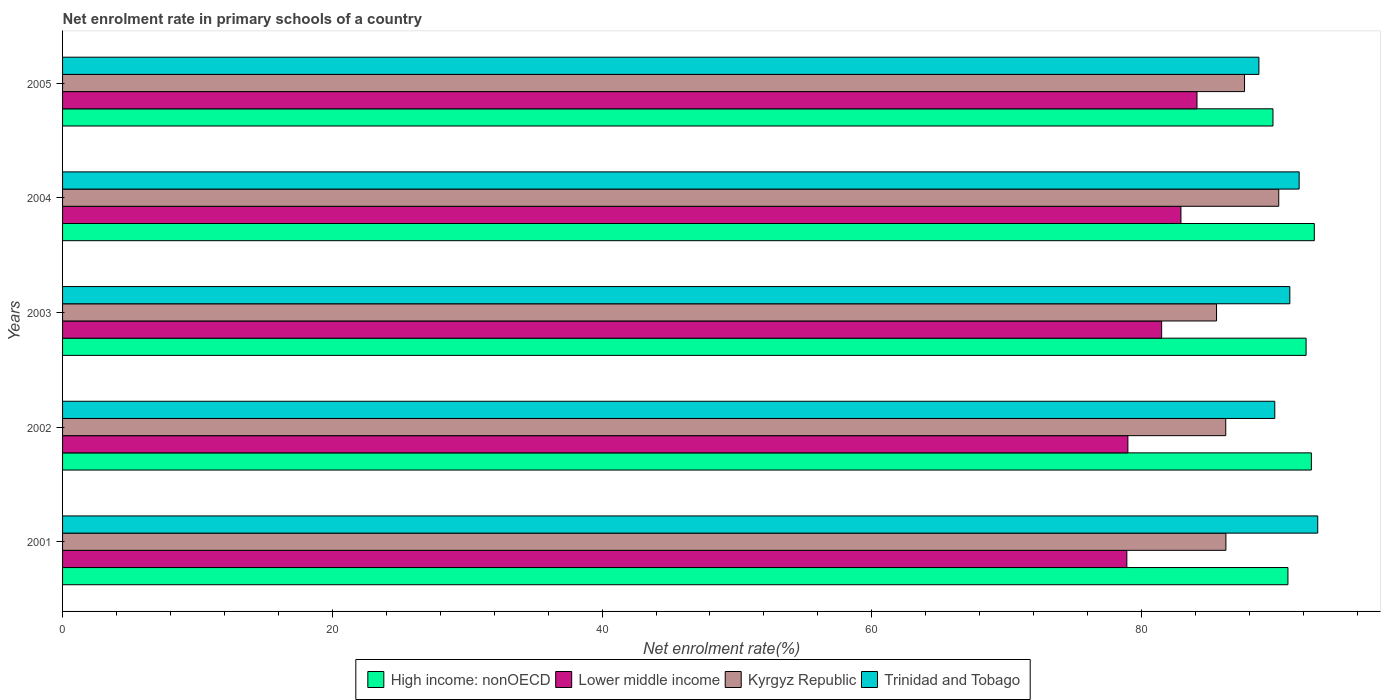How many bars are there on the 1st tick from the top?
Keep it short and to the point. 4. How many bars are there on the 5th tick from the bottom?
Give a very brief answer. 4. In how many cases, is the number of bars for a given year not equal to the number of legend labels?
Provide a short and direct response. 0. What is the net enrolment rate in primary schools in Lower middle income in 2004?
Your answer should be very brief. 82.92. Across all years, what is the maximum net enrolment rate in primary schools in High income: nonOECD?
Make the answer very short. 92.81. Across all years, what is the minimum net enrolment rate in primary schools in High income: nonOECD?
Offer a very short reply. 89.74. What is the total net enrolment rate in primary schools in Lower middle income in the graph?
Provide a short and direct response. 406.42. What is the difference between the net enrolment rate in primary schools in Trinidad and Tobago in 2002 and that in 2004?
Your response must be concise. -1.81. What is the difference between the net enrolment rate in primary schools in Trinidad and Tobago in 2001 and the net enrolment rate in primary schools in Kyrgyz Republic in 2003?
Make the answer very short. 7.5. What is the average net enrolment rate in primary schools in Lower middle income per year?
Your answer should be very brief. 81.28. In the year 2003, what is the difference between the net enrolment rate in primary schools in Kyrgyz Republic and net enrolment rate in primary schools in Trinidad and Tobago?
Keep it short and to the point. -5.43. In how many years, is the net enrolment rate in primary schools in Trinidad and Tobago greater than 44 %?
Offer a very short reply. 5. What is the ratio of the net enrolment rate in primary schools in Lower middle income in 2004 to that in 2005?
Your response must be concise. 0.99. Is the difference between the net enrolment rate in primary schools in Kyrgyz Republic in 2001 and 2004 greater than the difference between the net enrolment rate in primary schools in Trinidad and Tobago in 2001 and 2004?
Provide a short and direct response. No. What is the difference between the highest and the second highest net enrolment rate in primary schools in Trinidad and Tobago?
Ensure brevity in your answer.  1.38. What is the difference between the highest and the lowest net enrolment rate in primary schools in Trinidad and Tobago?
Your answer should be very brief. 4.36. In how many years, is the net enrolment rate in primary schools in Trinidad and Tobago greater than the average net enrolment rate in primary schools in Trinidad and Tobago taken over all years?
Your response must be concise. 3. What does the 1st bar from the top in 2004 represents?
Make the answer very short. Trinidad and Tobago. What does the 4th bar from the bottom in 2001 represents?
Ensure brevity in your answer.  Trinidad and Tobago. Is it the case that in every year, the sum of the net enrolment rate in primary schools in Kyrgyz Republic and net enrolment rate in primary schools in High income: nonOECD is greater than the net enrolment rate in primary schools in Trinidad and Tobago?
Make the answer very short. Yes. Are all the bars in the graph horizontal?
Provide a short and direct response. Yes. Are the values on the major ticks of X-axis written in scientific E-notation?
Provide a short and direct response. No. Does the graph contain any zero values?
Offer a very short reply. No. Does the graph contain grids?
Provide a succinct answer. No. Where does the legend appear in the graph?
Make the answer very short. Bottom center. What is the title of the graph?
Ensure brevity in your answer.  Net enrolment rate in primary schools of a country. What is the label or title of the X-axis?
Offer a terse response. Net enrolment rate(%). What is the Net enrolment rate(%) in High income: nonOECD in 2001?
Offer a very short reply. 90.85. What is the Net enrolment rate(%) of Lower middle income in 2001?
Offer a terse response. 78.91. What is the Net enrolment rate(%) in Kyrgyz Republic in 2001?
Offer a very short reply. 86.25. What is the Net enrolment rate(%) of Trinidad and Tobago in 2001?
Your response must be concise. 93.06. What is the Net enrolment rate(%) of High income: nonOECD in 2002?
Ensure brevity in your answer.  92.59. What is the Net enrolment rate(%) in Lower middle income in 2002?
Your answer should be compact. 78.99. What is the Net enrolment rate(%) of Kyrgyz Republic in 2002?
Your answer should be very brief. 86.24. What is the Net enrolment rate(%) in Trinidad and Tobago in 2002?
Offer a very short reply. 89.88. What is the Net enrolment rate(%) of High income: nonOECD in 2003?
Ensure brevity in your answer.  92.2. What is the Net enrolment rate(%) of Lower middle income in 2003?
Ensure brevity in your answer.  81.49. What is the Net enrolment rate(%) of Kyrgyz Republic in 2003?
Your answer should be very brief. 85.56. What is the Net enrolment rate(%) in Trinidad and Tobago in 2003?
Give a very brief answer. 90.99. What is the Net enrolment rate(%) in High income: nonOECD in 2004?
Offer a very short reply. 92.81. What is the Net enrolment rate(%) of Lower middle income in 2004?
Ensure brevity in your answer.  82.92. What is the Net enrolment rate(%) of Kyrgyz Republic in 2004?
Offer a very short reply. 90.17. What is the Net enrolment rate(%) of Trinidad and Tobago in 2004?
Provide a succinct answer. 91.68. What is the Net enrolment rate(%) of High income: nonOECD in 2005?
Provide a succinct answer. 89.74. What is the Net enrolment rate(%) of Lower middle income in 2005?
Keep it short and to the point. 84.11. What is the Net enrolment rate(%) in Kyrgyz Republic in 2005?
Ensure brevity in your answer.  87.64. What is the Net enrolment rate(%) of Trinidad and Tobago in 2005?
Keep it short and to the point. 88.7. Across all years, what is the maximum Net enrolment rate(%) of High income: nonOECD?
Offer a very short reply. 92.81. Across all years, what is the maximum Net enrolment rate(%) of Lower middle income?
Make the answer very short. 84.11. Across all years, what is the maximum Net enrolment rate(%) of Kyrgyz Republic?
Your answer should be compact. 90.17. Across all years, what is the maximum Net enrolment rate(%) of Trinidad and Tobago?
Offer a very short reply. 93.06. Across all years, what is the minimum Net enrolment rate(%) in High income: nonOECD?
Give a very brief answer. 89.74. Across all years, what is the minimum Net enrolment rate(%) of Lower middle income?
Your answer should be compact. 78.91. Across all years, what is the minimum Net enrolment rate(%) in Kyrgyz Republic?
Your answer should be very brief. 85.56. Across all years, what is the minimum Net enrolment rate(%) in Trinidad and Tobago?
Make the answer very short. 88.7. What is the total Net enrolment rate(%) of High income: nonOECD in the graph?
Your answer should be compact. 458.2. What is the total Net enrolment rate(%) of Lower middle income in the graph?
Ensure brevity in your answer.  406.42. What is the total Net enrolment rate(%) in Kyrgyz Republic in the graph?
Offer a very short reply. 435.86. What is the total Net enrolment rate(%) in Trinidad and Tobago in the graph?
Offer a terse response. 454.32. What is the difference between the Net enrolment rate(%) in High income: nonOECD in 2001 and that in 2002?
Give a very brief answer. -1.74. What is the difference between the Net enrolment rate(%) in Lower middle income in 2001 and that in 2002?
Your answer should be very brief. -0.08. What is the difference between the Net enrolment rate(%) in Kyrgyz Republic in 2001 and that in 2002?
Your response must be concise. 0.01. What is the difference between the Net enrolment rate(%) of Trinidad and Tobago in 2001 and that in 2002?
Your response must be concise. 3.18. What is the difference between the Net enrolment rate(%) of High income: nonOECD in 2001 and that in 2003?
Offer a very short reply. -1.35. What is the difference between the Net enrolment rate(%) in Lower middle income in 2001 and that in 2003?
Your response must be concise. -2.58. What is the difference between the Net enrolment rate(%) in Kyrgyz Republic in 2001 and that in 2003?
Your response must be concise. 0.7. What is the difference between the Net enrolment rate(%) in Trinidad and Tobago in 2001 and that in 2003?
Give a very brief answer. 2.07. What is the difference between the Net enrolment rate(%) in High income: nonOECD in 2001 and that in 2004?
Give a very brief answer. -1.96. What is the difference between the Net enrolment rate(%) of Lower middle income in 2001 and that in 2004?
Provide a short and direct response. -4.01. What is the difference between the Net enrolment rate(%) of Kyrgyz Republic in 2001 and that in 2004?
Provide a short and direct response. -3.92. What is the difference between the Net enrolment rate(%) in Trinidad and Tobago in 2001 and that in 2004?
Offer a very short reply. 1.38. What is the difference between the Net enrolment rate(%) in High income: nonOECD in 2001 and that in 2005?
Provide a succinct answer. 1.11. What is the difference between the Net enrolment rate(%) in Lower middle income in 2001 and that in 2005?
Provide a short and direct response. -5.2. What is the difference between the Net enrolment rate(%) of Kyrgyz Republic in 2001 and that in 2005?
Offer a very short reply. -1.38. What is the difference between the Net enrolment rate(%) of Trinidad and Tobago in 2001 and that in 2005?
Give a very brief answer. 4.36. What is the difference between the Net enrolment rate(%) of High income: nonOECD in 2002 and that in 2003?
Offer a terse response. 0.39. What is the difference between the Net enrolment rate(%) of Lower middle income in 2002 and that in 2003?
Your answer should be compact. -2.5. What is the difference between the Net enrolment rate(%) of Kyrgyz Republic in 2002 and that in 2003?
Give a very brief answer. 0.68. What is the difference between the Net enrolment rate(%) in Trinidad and Tobago in 2002 and that in 2003?
Ensure brevity in your answer.  -1.12. What is the difference between the Net enrolment rate(%) of High income: nonOECD in 2002 and that in 2004?
Offer a terse response. -0.22. What is the difference between the Net enrolment rate(%) of Lower middle income in 2002 and that in 2004?
Provide a succinct answer. -3.93. What is the difference between the Net enrolment rate(%) of Kyrgyz Republic in 2002 and that in 2004?
Offer a terse response. -3.93. What is the difference between the Net enrolment rate(%) of Trinidad and Tobago in 2002 and that in 2004?
Give a very brief answer. -1.81. What is the difference between the Net enrolment rate(%) of High income: nonOECD in 2002 and that in 2005?
Offer a terse response. 2.85. What is the difference between the Net enrolment rate(%) in Lower middle income in 2002 and that in 2005?
Your response must be concise. -5.12. What is the difference between the Net enrolment rate(%) of Kyrgyz Republic in 2002 and that in 2005?
Keep it short and to the point. -1.39. What is the difference between the Net enrolment rate(%) of Trinidad and Tobago in 2002 and that in 2005?
Make the answer very short. 1.18. What is the difference between the Net enrolment rate(%) of High income: nonOECD in 2003 and that in 2004?
Make the answer very short. -0.61. What is the difference between the Net enrolment rate(%) of Lower middle income in 2003 and that in 2004?
Offer a terse response. -1.43. What is the difference between the Net enrolment rate(%) of Kyrgyz Republic in 2003 and that in 2004?
Your response must be concise. -4.61. What is the difference between the Net enrolment rate(%) of Trinidad and Tobago in 2003 and that in 2004?
Give a very brief answer. -0.69. What is the difference between the Net enrolment rate(%) of High income: nonOECD in 2003 and that in 2005?
Ensure brevity in your answer.  2.46. What is the difference between the Net enrolment rate(%) in Lower middle income in 2003 and that in 2005?
Your answer should be compact. -2.62. What is the difference between the Net enrolment rate(%) in Kyrgyz Republic in 2003 and that in 2005?
Make the answer very short. -2.08. What is the difference between the Net enrolment rate(%) of Trinidad and Tobago in 2003 and that in 2005?
Provide a short and direct response. 2.29. What is the difference between the Net enrolment rate(%) of High income: nonOECD in 2004 and that in 2005?
Give a very brief answer. 3.06. What is the difference between the Net enrolment rate(%) in Lower middle income in 2004 and that in 2005?
Your response must be concise. -1.19. What is the difference between the Net enrolment rate(%) in Kyrgyz Republic in 2004 and that in 2005?
Make the answer very short. 2.54. What is the difference between the Net enrolment rate(%) of Trinidad and Tobago in 2004 and that in 2005?
Your answer should be very brief. 2.98. What is the difference between the Net enrolment rate(%) in High income: nonOECD in 2001 and the Net enrolment rate(%) in Lower middle income in 2002?
Your answer should be very brief. 11.87. What is the difference between the Net enrolment rate(%) in High income: nonOECD in 2001 and the Net enrolment rate(%) in Kyrgyz Republic in 2002?
Offer a terse response. 4.61. What is the difference between the Net enrolment rate(%) in High income: nonOECD in 2001 and the Net enrolment rate(%) in Trinidad and Tobago in 2002?
Provide a succinct answer. 0.98. What is the difference between the Net enrolment rate(%) in Lower middle income in 2001 and the Net enrolment rate(%) in Kyrgyz Republic in 2002?
Offer a very short reply. -7.33. What is the difference between the Net enrolment rate(%) of Lower middle income in 2001 and the Net enrolment rate(%) of Trinidad and Tobago in 2002?
Make the answer very short. -10.97. What is the difference between the Net enrolment rate(%) in Kyrgyz Republic in 2001 and the Net enrolment rate(%) in Trinidad and Tobago in 2002?
Provide a succinct answer. -3.62. What is the difference between the Net enrolment rate(%) of High income: nonOECD in 2001 and the Net enrolment rate(%) of Lower middle income in 2003?
Your answer should be very brief. 9.36. What is the difference between the Net enrolment rate(%) in High income: nonOECD in 2001 and the Net enrolment rate(%) in Kyrgyz Republic in 2003?
Ensure brevity in your answer.  5.29. What is the difference between the Net enrolment rate(%) in High income: nonOECD in 2001 and the Net enrolment rate(%) in Trinidad and Tobago in 2003?
Provide a short and direct response. -0.14. What is the difference between the Net enrolment rate(%) of Lower middle income in 2001 and the Net enrolment rate(%) of Kyrgyz Republic in 2003?
Ensure brevity in your answer.  -6.65. What is the difference between the Net enrolment rate(%) of Lower middle income in 2001 and the Net enrolment rate(%) of Trinidad and Tobago in 2003?
Give a very brief answer. -12.08. What is the difference between the Net enrolment rate(%) in Kyrgyz Republic in 2001 and the Net enrolment rate(%) in Trinidad and Tobago in 2003?
Ensure brevity in your answer.  -4.74. What is the difference between the Net enrolment rate(%) of High income: nonOECD in 2001 and the Net enrolment rate(%) of Lower middle income in 2004?
Provide a short and direct response. 7.93. What is the difference between the Net enrolment rate(%) in High income: nonOECD in 2001 and the Net enrolment rate(%) in Kyrgyz Republic in 2004?
Your answer should be very brief. 0.68. What is the difference between the Net enrolment rate(%) in High income: nonOECD in 2001 and the Net enrolment rate(%) in Trinidad and Tobago in 2004?
Provide a short and direct response. -0.83. What is the difference between the Net enrolment rate(%) of Lower middle income in 2001 and the Net enrolment rate(%) of Kyrgyz Republic in 2004?
Your answer should be compact. -11.26. What is the difference between the Net enrolment rate(%) in Lower middle income in 2001 and the Net enrolment rate(%) in Trinidad and Tobago in 2004?
Offer a very short reply. -12.77. What is the difference between the Net enrolment rate(%) in Kyrgyz Republic in 2001 and the Net enrolment rate(%) in Trinidad and Tobago in 2004?
Ensure brevity in your answer.  -5.43. What is the difference between the Net enrolment rate(%) of High income: nonOECD in 2001 and the Net enrolment rate(%) of Lower middle income in 2005?
Your answer should be compact. 6.74. What is the difference between the Net enrolment rate(%) in High income: nonOECD in 2001 and the Net enrolment rate(%) in Kyrgyz Republic in 2005?
Offer a terse response. 3.22. What is the difference between the Net enrolment rate(%) of High income: nonOECD in 2001 and the Net enrolment rate(%) of Trinidad and Tobago in 2005?
Your response must be concise. 2.15. What is the difference between the Net enrolment rate(%) of Lower middle income in 2001 and the Net enrolment rate(%) of Kyrgyz Republic in 2005?
Keep it short and to the point. -8.73. What is the difference between the Net enrolment rate(%) in Lower middle income in 2001 and the Net enrolment rate(%) in Trinidad and Tobago in 2005?
Ensure brevity in your answer.  -9.79. What is the difference between the Net enrolment rate(%) of Kyrgyz Republic in 2001 and the Net enrolment rate(%) of Trinidad and Tobago in 2005?
Provide a succinct answer. -2.45. What is the difference between the Net enrolment rate(%) in High income: nonOECD in 2002 and the Net enrolment rate(%) in Lower middle income in 2003?
Offer a terse response. 11.1. What is the difference between the Net enrolment rate(%) in High income: nonOECD in 2002 and the Net enrolment rate(%) in Kyrgyz Republic in 2003?
Keep it short and to the point. 7.03. What is the difference between the Net enrolment rate(%) in High income: nonOECD in 2002 and the Net enrolment rate(%) in Trinidad and Tobago in 2003?
Your answer should be compact. 1.6. What is the difference between the Net enrolment rate(%) in Lower middle income in 2002 and the Net enrolment rate(%) in Kyrgyz Republic in 2003?
Make the answer very short. -6.57. What is the difference between the Net enrolment rate(%) in Lower middle income in 2002 and the Net enrolment rate(%) in Trinidad and Tobago in 2003?
Offer a very short reply. -12.01. What is the difference between the Net enrolment rate(%) in Kyrgyz Republic in 2002 and the Net enrolment rate(%) in Trinidad and Tobago in 2003?
Give a very brief answer. -4.75. What is the difference between the Net enrolment rate(%) in High income: nonOECD in 2002 and the Net enrolment rate(%) in Lower middle income in 2004?
Offer a terse response. 9.67. What is the difference between the Net enrolment rate(%) of High income: nonOECD in 2002 and the Net enrolment rate(%) of Kyrgyz Republic in 2004?
Provide a succinct answer. 2.42. What is the difference between the Net enrolment rate(%) in High income: nonOECD in 2002 and the Net enrolment rate(%) in Trinidad and Tobago in 2004?
Make the answer very short. 0.91. What is the difference between the Net enrolment rate(%) in Lower middle income in 2002 and the Net enrolment rate(%) in Kyrgyz Republic in 2004?
Provide a short and direct response. -11.19. What is the difference between the Net enrolment rate(%) of Lower middle income in 2002 and the Net enrolment rate(%) of Trinidad and Tobago in 2004?
Give a very brief answer. -12.7. What is the difference between the Net enrolment rate(%) in Kyrgyz Republic in 2002 and the Net enrolment rate(%) in Trinidad and Tobago in 2004?
Give a very brief answer. -5.44. What is the difference between the Net enrolment rate(%) of High income: nonOECD in 2002 and the Net enrolment rate(%) of Lower middle income in 2005?
Your answer should be very brief. 8.48. What is the difference between the Net enrolment rate(%) of High income: nonOECD in 2002 and the Net enrolment rate(%) of Kyrgyz Republic in 2005?
Offer a terse response. 4.96. What is the difference between the Net enrolment rate(%) of High income: nonOECD in 2002 and the Net enrolment rate(%) of Trinidad and Tobago in 2005?
Make the answer very short. 3.89. What is the difference between the Net enrolment rate(%) in Lower middle income in 2002 and the Net enrolment rate(%) in Kyrgyz Republic in 2005?
Your response must be concise. -8.65. What is the difference between the Net enrolment rate(%) in Lower middle income in 2002 and the Net enrolment rate(%) in Trinidad and Tobago in 2005?
Offer a very short reply. -9.71. What is the difference between the Net enrolment rate(%) of Kyrgyz Republic in 2002 and the Net enrolment rate(%) of Trinidad and Tobago in 2005?
Offer a terse response. -2.46. What is the difference between the Net enrolment rate(%) in High income: nonOECD in 2003 and the Net enrolment rate(%) in Lower middle income in 2004?
Provide a short and direct response. 9.28. What is the difference between the Net enrolment rate(%) of High income: nonOECD in 2003 and the Net enrolment rate(%) of Kyrgyz Republic in 2004?
Provide a succinct answer. 2.03. What is the difference between the Net enrolment rate(%) of High income: nonOECD in 2003 and the Net enrolment rate(%) of Trinidad and Tobago in 2004?
Give a very brief answer. 0.52. What is the difference between the Net enrolment rate(%) in Lower middle income in 2003 and the Net enrolment rate(%) in Kyrgyz Republic in 2004?
Keep it short and to the point. -8.68. What is the difference between the Net enrolment rate(%) in Lower middle income in 2003 and the Net enrolment rate(%) in Trinidad and Tobago in 2004?
Ensure brevity in your answer.  -10.2. What is the difference between the Net enrolment rate(%) in Kyrgyz Republic in 2003 and the Net enrolment rate(%) in Trinidad and Tobago in 2004?
Provide a succinct answer. -6.12. What is the difference between the Net enrolment rate(%) of High income: nonOECD in 2003 and the Net enrolment rate(%) of Lower middle income in 2005?
Your answer should be compact. 8.09. What is the difference between the Net enrolment rate(%) in High income: nonOECD in 2003 and the Net enrolment rate(%) in Kyrgyz Republic in 2005?
Give a very brief answer. 4.56. What is the difference between the Net enrolment rate(%) of High income: nonOECD in 2003 and the Net enrolment rate(%) of Trinidad and Tobago in 2005?
Make the answer very short. 3.5. What is the difference between the Net enrolment rate(%) in Lower middle income in 2003 and the Net enrolment rate(%) in Kyrgyz Republic in 2005?
Give a very brief answer. -6.15. What is the difference between the Net enrolment rate(%) of Lower middle income in 2003 and the Net enrolment rate(%) of Trinidad and Tobago in 2005?
Ensure brevity in your answer.  -7.21. What is the difference between the Net enrolment rate(%) in Kyrgyz Republic in 2003 and the Net enrolment rate(%) in Trinidad and Tobago in 2005?
Your response must be concise. -3.14. What is the difference between the Net enrolment rate(%) in High income: nonOECD in 2004 and the Net enrolment rate(%) in Lower middle income in 2005?
Your answer should be very brief. 8.7. What is the difference between the Net enrolment rate(%) in High income: nonOECD in 2004 and the Net enrolment rate(%) in Kyrgyz Republic in 2005?
Give a very brief answer. 5.17. What is the difference between the Net enrolment rate(%) of High income: nonOECD in 2004 and the Net enrolment rate(%) of Trinidad and Tobago in 2005?
Your answer should be compact. 4.11. What is the difference between the Net enrolment rate(%) in Lower middle income in 2004 and the Net enrolment rate(%) in Kyrgyz Republic in 2005?
Offer a very short reply. -4.71. What is the difference between the Net enrolment rate(%) in Lower middle income in 2004 and the Net enrolment rate(%) in Trinidad and Tobago in 2005?
Give a very brief answer. -5.78. What is the difference between the Net enrolment rate(%) of Kyrgyz Republic in 2004 and the Net enrolment rate(%) of Trinidad and Tobago in 2005?
Offer a terse response. 1.47. What is the average Net enrolment rate(%) of High income: nonOECD per year?
Keep it short and to the point. 91.64. What is the average Net enrolment rate(%) of Lower middle income per year?
Provide a succinct answer. 81.28. What is the average Net enrolment rate(%) of Kyrgyz Republic per year?
Your response must be concise. 87.17. What is the average Net enrolment rate(%) of Trinidad and Tobago per year?
Offer a terse response. 90.86. In the year 2001, what is the difference between the Net enrolment rate(%) of High income: nonOECD and Net enrolment rate(%) of Lower middle income?
Offer a terse response. 11.94. In the year 2001, what is the difference between the Net enrolment rate(%) of High income: nonOECD and Net enrolment rate(%) of Kyrgyz Republic?
Ensure brevity in your answer.  4.6. In the year 2001, what is the difference between the Net enrolment rate(%) of High income: nonOECD and Net enrolment rate(%) of Trinidad and Tobago?
Offer a very short reply. -2.21. In the year 2001, what is the difference between the Net enrolment rate(%) in Lower middle income and Net enrolment rate(%) in Kyrgyz Republic?
Ensure brevity in your answer.  -7.34. In the year 2001, what is the difference between the Net enrolment rate(%) in Lower middle income and Net enrolment rate(%) in Trinidad and Tobago?
Offer a terse response. -14.15. In the year 2001, what is the difference between the Net enrolment rate(%) of Kyrgyz Republic and Net enrolment rate(%) of Trinidad and Tobago?
Ensure brevity in your answer.  -6.81. In the year 2002, what is the difference between the Net enrolment rate(%) in High income: nonOECD and Net enrolment rate(%) in Lower middle income?
Your response must be concise. 13.6. In the year 2002, what is the difference between the Net enrolment rate(%) in High income: nonOECD and Net enrolment rate(%) in Kyrgyz Republic?
Ensure brevity in your answer.  6.35. In the year 2002, what is the difference between the Net enrolment rate(%) in High income: nonOECD and Net enrolment rate(%) in Trinidad and Tobago?
Your answer should be very brief. 2.71. In the year 2002, what is the difference between the Net enrolment rate(%) of Lower middle income and Net enrolment rate(%) of Kyrgyz Republic?
Provide a short and direct response. -7.26. In the year 2002, what is the difference between the Net enrolment rate(%) in Lower middle income and Net enrolment rate(%) in Trinidad and Tobago?
Provide a short and direct response. -10.89. In the year 2002, what is the difference between the Net enrolment rate(%) of Kyrgyz Republic and Net enrolment rate(%) of Trinidad and Tobago?
Provide a short and direct response. -3.64. In the year 2003, what is the difference between the Net enrolment rate(%) in High income: nonOECD and Net enrolment rate(%) in Lower middle income?
Offer a very short reply. 10.71. In the year 2003, what is the difference between the Net enrolment rate(%) of High income: nonOECD and Net enrolment rate(%) of Kyrgyz Republic?
Provide a short and direct response. 6.64. In the year 2003, what is the difference between the Net enrolment rate(%) of High income: nonOECD and Net enrolment rate(%) of Trinidad and Tobago?
Your response must be concise. 1.21. In the year 2003, what is the difference between the Net enrolment rate(%) of Lower middle income and Net enrolment rate(%) of Kyrgyz Republic?
Your response must be concise. -4.07. In the year 2003, what is the difference between the Net enrolment rate(%) of Lower middle income and Net enrolment rate(%) of Trinidad and Tobago?
Give a very brief answer. -9.5. In the year 2003, what is the difference between the Net enrolment rate(%) in Kyrgyz Republic and Net enrolment rate(%) in Trinidad and Tobago?
Keep it short and to the point. -5.43. In the year 2004, what is the difference between the Net enrolment rate(%) of High income: nonOECD and Net enrolment rate(%) of Lower middle income?
Offer a terse response. 9.89. In the year 2004, what is the difference between the Net enrolment rate(%) of High income: nonOECD and Net enrolment rate(%) of Kyrgyz Republic?
Offer a very short reply. 2.64. In the year 2004, what is the difference between the Net enrolment rate(%) in High income: nonOECD and Net enrolment rate(%) in Trinidad and Tobago?
Your answer should be very brief. 1.12. In the year 2004, what is the difference between the Net enrolment rate(%) of Lower middle income and Net enrolment rate(%) of Kyrgyz Republic?
Offer a terse response. -7.25. In the year 2004, what is the difference between the Net enrolment rate(%) in Lower middle income and Net enrolment rate(%) in Trinidad and Tobago?
Give a very brief answer. -8.76. In the year 2004, what is the difference between the Net enrolment rate(%) of Kyrgyz Republic and Net enrolment rate(%) of Trinidad and Tobago?
Make the answer very short. -1.51. In the year 2005, what is the difference between the Net enrolment rate(%) of High income: nonOECD and Net enrolment rate(%) of Lower middle income?
Keep it short and to the point. 5.63. In the year 2005, what is the difference between the Net enrolment rate(%) in High income: nonOECD and Net enrolment rate(%) in Kyrgyz Republic?
Make the answer very short. 2.11. In the year 2005, what is the difference between the Net enrolment rate(%) in High income: nonOECD and Net enrolment rate(%) in Trinidad and Tobago?
Your response must be concise. 1.04. In the year 2005, what is the difference between the Net enrolment rate(%) of Lower middle income and Net enrolment rate(%) of Kyrgyz Republic?
Give a very brief answer. -3.53. In the year 2005, what is the difference between the Net enrolment rate(%) of Lower middle income and Net enrolment rate(%) of Trinidad and Tobago?
Offer a terse response. -4.59. In the year 2005, what is the difference between the Net enrolment rate(%) of Kyrgyz Republic and Net enrolment rate(%) of Trinidad and Tobago?
Provide a short and direct response. -1.06. What is the ratio of the Net enrolment rate(%) in High income: nonOECD in 2001 to that in 2002?
Your response must be concise. 0.98. What is the ratio of the Net enrolment rate(%) of Lower middle income in 2001 to that in 2002?
Make the answer very short. 1. What is the ratio of the Net enrolment rate(%) in Trinidad and Tobago in 2001 to that in 2002?
Offer a very short reply. 1.04. What is the ratio of the Net enrolment rate(%) of High income: nonOECD in 2001 to that in 2003?
Your answer should be compact. 0.99. What is the ratio of the Net enrolment rate(%) of Lower middle income in 2001 to that in 2003?
Your answer should be compact. 0.97. What is the ratio of the Net enrolment rate(%) in Kyrgyz Republic in 2001 to that in 2003?
Give a very brief answer. 1.01. What is the ratio of the Net enrolment rate(%) of Trinidad and Tobago in 2001 to that in 2003?
Provide a short and direct response. 1.02. What is the ratio of the Net enrolment rate(%) in High income: nonOECD in 2001 to that in 2004?
Your answer should be very brief. 0.98. What is the ratio of the Net enrolment rate(%) of Lower middle income in 2001 to that in 2004?
Give a very brief answer. 0.95. What is the ratio of the Net enrolment rate(%) in Kyrgyz Republic in 2001 to that in 2004?
Offer a terse response. 0.96. What is the ratio of the Net enrolment rate(%) in High income: nonOECD in 2001 to that in 2005?
Keep it short and to the point. 1.01. What is the ratio of the Net enrolment rate(%) of Lower middle income in 2001 to that in 2005?
Give a very brief answer. 0.94. What is the ratio of the Net enrolment rate(%) of Kyrgyz Republic in 2001 to that in 2005?
Keep it short and to the point. 0.98. What is the ratio of the Net enrolment rate(%) in Trinidad and Tobago in 2001 to that in 2005?
Your answer should be compact. 1.05. What is the ratio of the Net enrolment rate(%) in Lower middle income in 2002 to that in 2003?
Provide a succinct answer. 0.97. What is the ratio of the Net enrolment rate(%) in Trinidad and Tobago in 2002 to that in 2003?
Your response must be concise. 0.99. What is the ratio of the Net enrolment rate(%) in High income: nonOECD in 2002 to that in 2004?
Keep it short and to the point. 1. What is the ratio of the Net enrolment rate(%) in Lower middle income in 2002 to that in 2004?
Give a very brief answer. 0.95. What is the ratio of the Net enrolment rate(%) of Kyrgyz Republic in 2002 to that in 2004?
Offer a terse response. 0.96. What is the ratio of the Net enrolment rate(%) in Trinidad and Tobago in 2002 to that in 2004?
Offer a terse response. 0.98. What is the ratio of the Net enrolment rate(%) in High income: nonOECD in 2002 to that in 2005?
Keep it short and to the point. 1.03. What is the ratio of the Net enrolment rate(%) of Lower middle income in 2002 to that in 2005?
Ensure brevity in your answer.  0.94. What is the ratio of the Net enrolment rate(%) of Kyrgyz Republic in 2002 to that in 2005?
Your answer should be very brief. 0.98. What is the ratio of the Net enrolment rate(%) in Trinidad and Tobago in 2002 to that in 2005?
Offer a very short reply. 1.01. What is the ratio of the Net enrolment rate(%) of High income: nonOECD in 2003 to that in 2004?
Your answer should be compact. 0.99. What is the ratio of the Net enrolment rate(%) in Lower middle income in 2003 to that in 2004?
Your answer should be compact. 0.98. What is the ratio of the Net enrolment rate(%) of Kyrgyz Republic in 2003 to that in 2004?
Provide a short and direct response. 0.95. What is the ratio of the Net enrolment rate(%) in Trinidad and Tobago in 2003 to that in 2004?
Offer a terse response. 0.99. What is the ratio of the Net enrolment rate(%) of High income: nonOECD in 2003 to that in 2005?
Your answer should be very brief. 1.03. What is the ratio of the Net enrolment rate(%) of Lower middle income in 2003 to that in 2005?
Offer a very short reply. 0.97. What is the ratio of the Net enrolment rate(%) in Kyrgyz Republic in 2003 to that in 2005?
Provide a short and direct response. 0.98. What is the ratio of the Net enrolment rate(%) of Trinidad and Tobago in 2003 to that in 2005?
Ensure brevity in your answer.  1.03. What is the ratio of the Net enrolment rate(%) of High income: nonOECD in 2004 to that in 2005?
Ensure brevity in your answer.  1.03. What is the ratio of the Net enrolment rate(%) of Lower middle income in 2004 to that in 2005?
Provide a succinct answer. 0.99. What is the ratio of the Net enrolment rate(%) of Kyrgyz Republic in 2004 to that in 2005?
Offer a very short reply. 1.03. What is the ratio of the Net enrolment rate(%) of Trinidad and Tobago in 2004 to that in 2005?
Provide a succinct answer. 1.03. What is the difference between the highest and the second highest Net enrolment rate(%) of High income: nonOECD?
Offer a very short reply. 0.22. What is the difference between the highest and the second highest Net enrolment rate(%) of Lower middle income?
Offer a terse response. 1.19. What is the difference between the highest and the second highest Net enrolment rate(%) of Kyrgyz Republic?
Make the answer very short. 2.54. What is the difference between the highest and the second highest Net enrolment rate(%) in Trinidad and Tobago?
Provide a short and direct response. 1.38. What is the difference between the highest and the lowest Net enrolment rate(%) in High income: nonOECD?
Give a very brief answer. 3.06. What is the difference between the highest and the lowest Net enrolment rate(%) in Lower middle income?
Offer a very short reply. 5.2. What is the difference between the highest and the lowest Net enrolment rate(%) in Kyrgyz Republic?
Your response must be concise. 4.61. What is the difference between the highest and the lowest Net enrolment rate(%) in Trinidad and Tobago?
Provide a short and direct response. 4.36. 